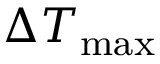<formula> <loc_0><loc_0><loc_500><loc_500>\Delta { T _ { \max } }</formula> 